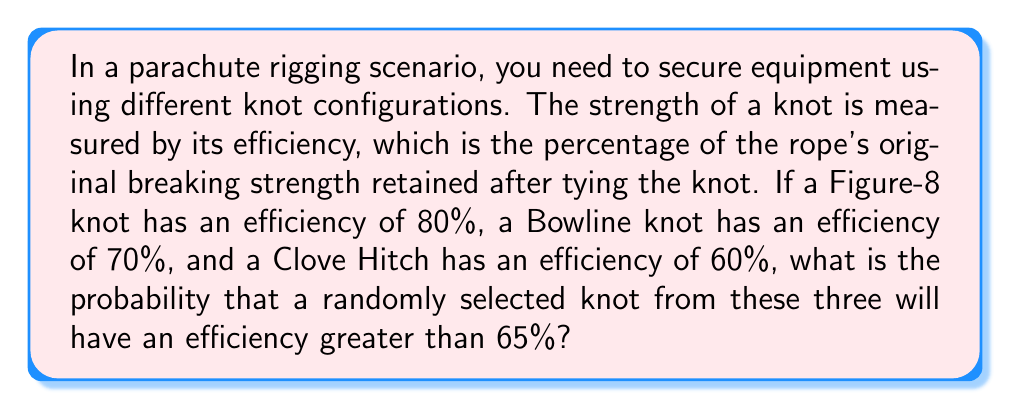Show me your answer to this math problem. Let's approach this step-by-step:

1) First, we need to identify which knots have an efficiency greater than 65%:
   - Figure-8 knot: 80% > 65%
   - Bowline knot: 70% > 65%
   - Clove Hitch: 60% < 65%

2) We can see that 2 out of the 3 knots meet the criteria.

3) To calculate the probability, we use the formula:

   $$P(\text{efficiency} > 65\%) = \frac{\text{Number of favorable outcomes}}{\text{Total number of possible outcomes}}$$

4) In this case:
   - Number of favorable outcomes = 2 (Figure-8 and Bowline)
   - Total number of possible outcomes = 3 (all knots)

5) Substituting these values into our probability formula:

   $$P(\text{efficiency} > 65\%) = \frac{2}{3}$$

6) This can be expressed as a decimal: $\frac{2}{3} \approx 0.6667$ or as a percentage: $66.67\%$

Therefore, the probability of randomly selecting a knot with an efficiency greater than 65% is $\frac{2}{3}$ or approximately 66.67%.
Answer: $\frac{2}{3}$ 